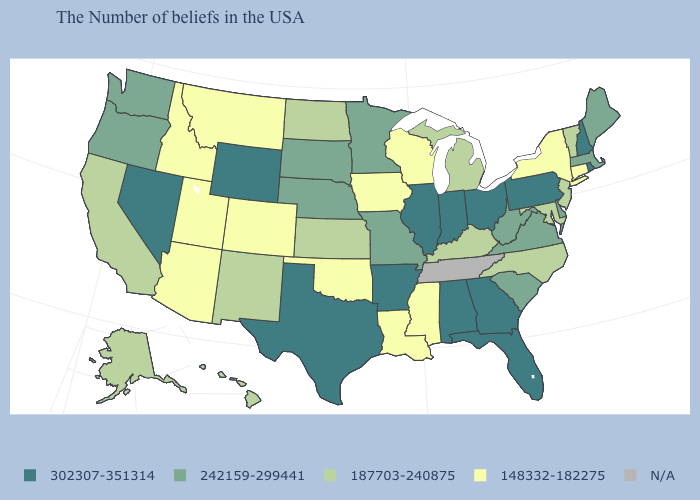What is the lowest value in the USA?
Answer briefly. 148332-182275. What is the value of North Dakota?
Give a very brief answer. 187703-240875. How many symbols are there in the legend?
Concise answer only. 5. What is the highest value in the USA?
Short answer required. 302307-351314. Name the states that have a value in the range 187703-240875?
Short answer required. Vermont, New Jersey, Maryland, North Carolina, Michigan, Kentucky, Kansas, North Dakota, New Mexico, California, Alaska, Hawaii. Name the states that have a value in the range N/A?
Give a very brief answer. Tennessee. Name the states that have a value in the range 148332-182275?
Concise answer only. Connecticut, New York, Wisconsin, Mississippi, Louisiana, Iowa, Oklahoma, Colorado, Utah, Montana, Arizona, Idaho. Does the map have missing data?
Keep it brief. Yes. What is the value of Arkansas?
Concise answer only. 302307-351314. Name the states that have a value in the range 302307-351314?
Quick response, please. Rhode Island, New Hampshire, Pennsylvania, Ohio, Florida, Georgia, Indiana, Alabama, Illinois, Arkansas, Texas, Wyoming, Nevada. Among the states that border Louisiana , does Mississippi have the highest value?
Quick response, please. No. Name the states that have a value in the range 187703-240875?
Short answer required. Vermont, New Jersey, Maryland, North Carolina, Michigan, Kentucky, Kansas, North Dakota, New Mexico, California, Alaska, Hawaii. 